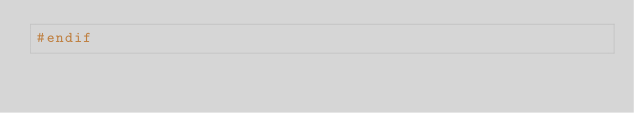Convert code to text. <code><loc_0><loc_0><loc_500><loc_500><_C_>#endif
</code> 